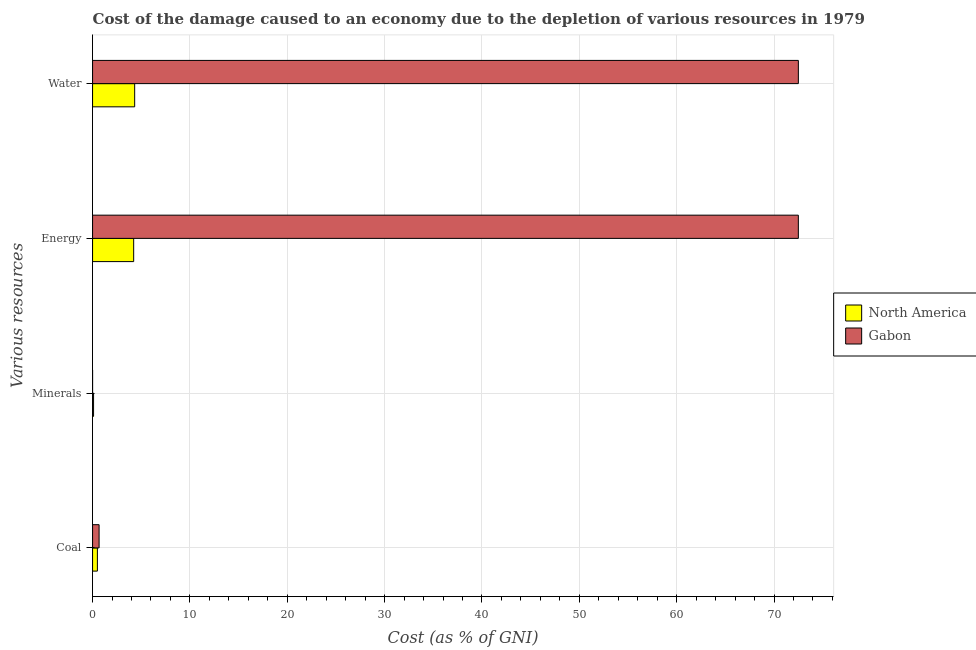How many groups of bars are there?
Provide a succinct answer. 4. Are the number of bars on each tick of the Y-axis equal?
Give a very brief answer. Yes. How many bars are there on the 4th tick from the bottom?
Offer a terse response. 2. What is the label of the 2nd group of bars from the top?
Make the answer very short. Energy. What is the cost of damage due to depletion of minerals in Gabon?
Provide a short and direct response. 0. Across all countries, what is the maximum cost of damage due to depletion of minerals?
Your answer should be very brief. 0.1. Across all countries, what is the minimum cost of damage due to depletion of water?
Your response must be concise. 4.32. In which country was the cost of damage due to depletion of coal maximum?
Give a very brief answer. Gabon. What is the total cost of damage due to depletion of energy in the graph?
Make the answer very short. 76.72. What is the difference between the cost of damage due to depletion of coal in North America and that in Gabon?
Offer a very short reply. -0.17. What is the difference between the cost of damage due to depletion of energy in North America and the cost of damage due to depletion of coal in Gabon?
Your answer should be compact. 3.55. What is the average cost of damage due to depletion of energy per country?
Provide a succinct answer. 38.36. What is the difference between the cost of damage due to depletion of coal and cost of damage due to depletion of minerals in Gabon?
Your response must be concise. 0.67. What is the ratio of the cost of damage due to depletion of water in Gabon to that in North America?
Your answer should be compact. 16.76. Is the cost of damage due to depletion of energy in North America less than that in Gabon?
Offer a terse response. Yes. What is the difference between the highest and the second highest cost of damage due to depletion of water?
Ensure brevity in your answer.  68.17. What is the difference between the highest and the lowest cost of damage due to depletion of energy?
Keep it short and to the point. 68.27. In how many countries, is the cost of damage due to depletion of energy greater than the average cost of damage due to depletion of energy taken over all countries?
Provide a short and direct response. 1. What does the 2nd bar from the top in Coal represents?
Ensure brevity in your answer.  North America. How many bars are there?
Provide a succinct answer. 8. Are all the bars in the graph horizontal?
Offer a terse response. Yes. How are the legend labels stacked?
Provide a short and direct response. Vertical. What is the title of the graph?
Ensure brevity in your answer.  Cost of the damage caused to an economy due to the depletion of various resources in 1979 . What is the label or title of the X-axis?
Your answer should be compact. Cost (as % of GNI). What is the label or title of the Y-axis?
Offer a very short reply. Various resources. What is the Cost (as % of GNI) in North America in Coal?
Provide a succinct answer. 0.5. What is the Cost (as % of GNI) in Gabon in Coal?
Give a very brief answer. 0.67. What is the Cost (as % of GNI) in North America in Minerals?
Give a very brief answer. 0.1. What is the Cost (as % of GNI) of Gabon in Minerals?
Ensure brevity in your answer.  0. What is the Cost (as % of GNI) of North America in Energy?
Provide a short and direct response. 4.22. What is the Cost (as % of GNI) of Gabon in Energy?
Ensure brevity in your answer.  72.5. What is the Cost (as % of GNI) in North America in Water?
Keep it short and to the point. 4.32. What is the Cost (as % of GNI) of Gabon in Water?
Provide a short and direct response. 72.5. Across all Various resources, what is the maximum Cost (as % of GNI) of North America?
Offer a very short reply. 4.32. Across all Various resources, what is the maximum Cost (as % of GNI) of Gabon?
Offer a terse response. 72.5. Across all Various resources, what is the minimum Cost (as % of GNI) in North America?
Give a very brief answer. 0.1. Across all Various resources, what is the minimum Cost (as % of GNI) of Gabon?
Ensure brevity in your answer.  0. What is the total Cost (as % of GNI) in North America in the graph?
Keep it short and to the point. 9.14. What is the total Cost (as % of GNI) of Gabon in the graph?
Keep it short and to the point. 145.67. What is the difference between the Cost (as % of GNI) in North America in Coal and that in Minerals?
Keep it short and to the point. 0.39. What is the difference between the Cost (as % of GNI) of Gabon in Coal and that in Minerals?
Keep it short and to the point. 0.67. What is the difference between the Cost (as % of GNI) of North America in Coal and that in Energy?
Offer a terse response. -3.73. What is the difference between the Cost (as % of GNI) of Gabon in Coal and that in Energy?
Your answer should be very brief. -71.83. What is the difference between the Cost (as % of GNI) in North America in Coal and that in Water?
Offer a terse response. -3.83. What is the difference between the Cost (as % of GNI) of Gabon in Coal and that in Water?
Keep it short and to the point. -71.83. What is the difference between the Cost (as % of GNI) of North America in Minerals and that in Energy?
Provide a succinct answer. -4.12. What is the difference between the Cost (as % of GNI) in Gabon in Minerals and that in Energy?
Provide a short and direct response. -72.5. What is the difference between the Cost (as % of GNI) of North America in Minerals and that in Water?
Provide a succinct answer. -4.22. What is the difference between the Cost (as % of GNI) in Gabon in Minerals and that in Water?
Offer a very short reply. -72.5. What is the difference between the Cost (as % of GNI) of North America in Energy and that in Water?
Your answer should be compact. -0.1. What is the difference between the Cost (as % of GNI) of Gabon in Energy and that in Water?
Give a very brief answer. -0. What is the difference between the Cost (as % of GNI) in North America in Coal and the Cost (as % of GNI) in Gabon in Minerals?
Keep it short and to the point. 0.49. What is the difference between the Cost (as % of GNI) in North America in Coal and the Cost (as % of GNI) in Gabon in Energy?
Keep it short and to the point. -72. What is the difference between the Cost (as % of GNI) in North America in Coal and the Cost (as % of GNI) in Gabon in Water?
Your answer should be very brief. -72. What is the difference between the Cost (as % of GNI) of North America in Minerals and the Cost (as % of GNI) of Gabon in Energy?
Provide a short and direct response. -72.39. What is the difference between the Cost (as % of GNI) in North America in Minerals and the Cost (as % of GNI) in Gabon in Water?
Your answer should be compact. -72.4. What is the difference between the Cost (as % of GNI) of North America in Energy and the Cost (as % of GNI) of Gabon in Water?
Offer a very short reply. -68.28. What is the average Cost (as % of GNI) in North America per Various resources?
Ensure brevity in your answer.  2.29. What is the average Cost (as % of GNI) in Gabon per Various resources?
Keep it short and to the point. 36.42. What is the difference between the Cost (as % of GNI) in North America and Cost (as % of GNI) in Gabon in Coal?
Your response must be concise. -0.17. What is the difference between the Cost (as % of GNI) of North America and Cost (as % of GNI) of Gabon in Minerals?
Offer a terse response. 0.1. What is the difference between the Cost (as % of GNI) of North America and Cost (as % of GNI) of Gabon in Energy?
Make the answer very short. -68.27. What is the difference between the Cost (as % of GNI) in North America and Cost (as % of GNI) in Gabon in Water?
Make the answer very short. -68.17. What is the ratio of the Cost (as % of GNI) in North America in Coal to that in Minerals?
Keep it short and to the point. 4.86. What is the ratio of the Cost (as % of GNI) in Gabon in Coal to that in Minerals?
Your response must be concise. 514.03. What is the ratio of the Cost (as % of GNI) in North America in Coal to that in Energy?
Ensure brevity in your answer.  0.12. What is the ratio of the Cost (as % of GNI) of Gabon in Coal to that in Energy?
Your response must be concise. 0.01. What is the ratio of the Cost (as % of GNI) in North America in Coal to that in Water?
Offer a terse response. 0.11. What is the ratio of the Cost (as % of GNI) of Gabon in Coal to that in Water?
Your answer should be very brief. 0.01. What is the ratio of the Cost (as % of GNI) of North America in Minerals to that in Energy?
Your answer should be very brief. 0.02. What is the ratio of the Cost (as % of GNI) of North America in Minerals to that in Water?
Provide a short and direct response. 0.02. What is the ratio of the Cost (as % of GNI) of North America in Energy to that in Water?
Give a very brief answer. 0.98. What is the difference between the highest and the second highest Cost (as % of GNI) in North America?
Ensure brevity in your answer.  0.1. What is the difference between the highest and the second highest Cost (as % of GNI) of Gabon?
Provide a short and direct response. 0. What is the difference between the highest and the lowest Cost (as % of GNI) of North America?
Offer a terse response. 4.22. What is the difference between the highest and the lowest Cost (as % of GNI) of Gabon?
Provide a short and direct response. 72.5. 